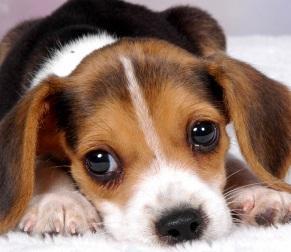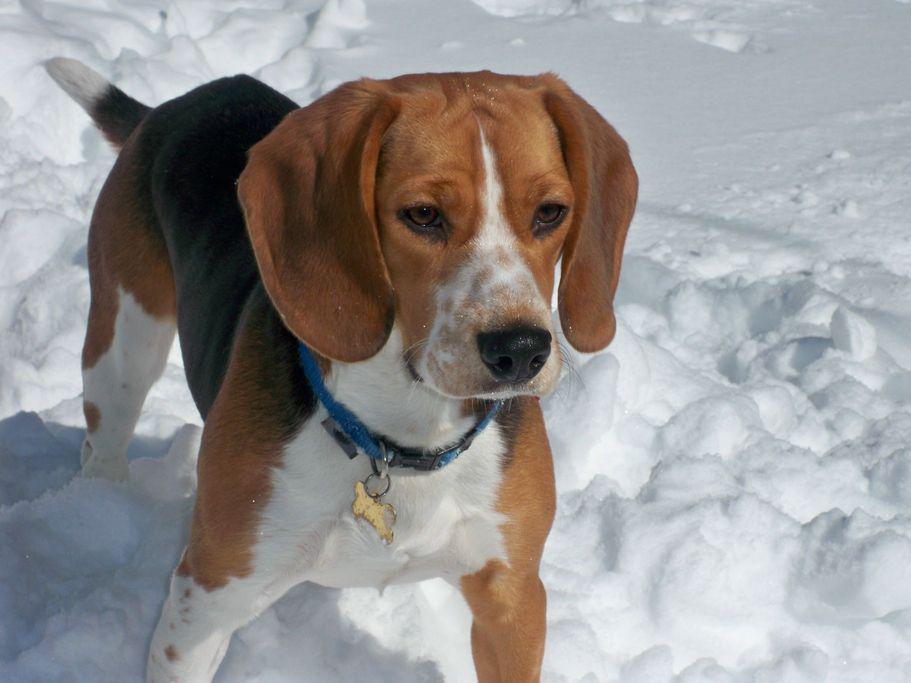The first image is the image on the left, the second image is the image on the right. For the images displayed, is the sentence "Each image shows exactly one beagle, but the beagle on the right is older with a longer muzzle and is posed on an outdoor surface." factually correct? Answer yes or no. Yes. The first image is the image on the left, the second image is the image on the right. Assess this claim about the two images: "The dog on the right is photographed in snow and has a white line going upwards from his nose to his forehead.". Correct or not? Answer yes or no. Yes. 